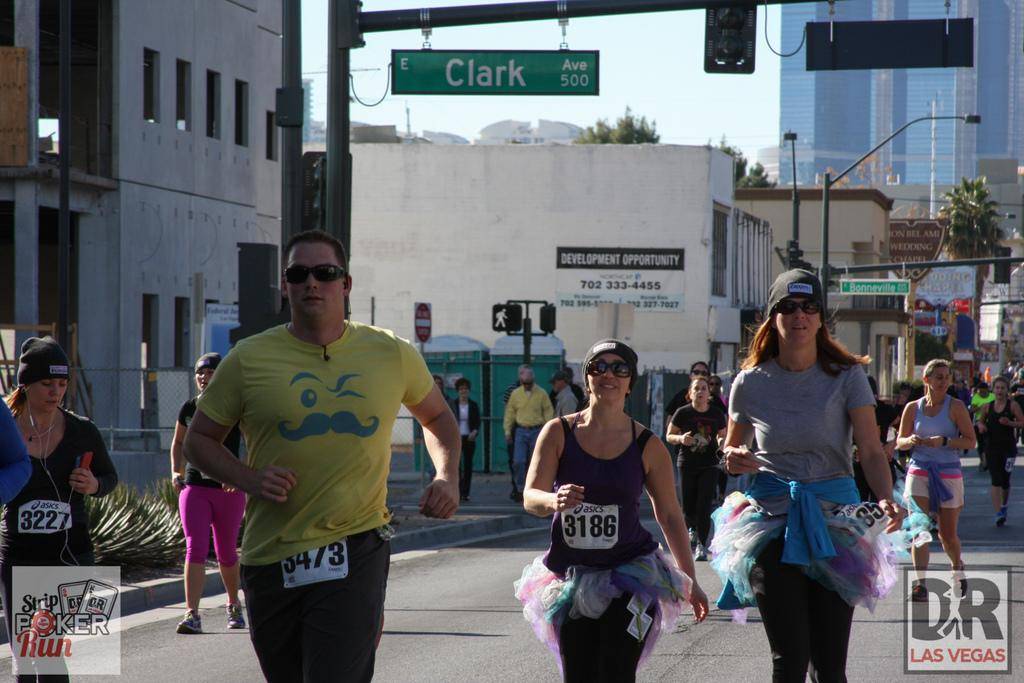What are the people in the image doing? The people in the center of the image are walking and running. What can be seen in the background of the image? There are buildings, poles, trees, and boards with text written on them in the background of the image. What type of destruction can be seen in the image? There is no destruction present in the image; it features people walking and running, as well as various background elements. What type of eggnog is being served in the image? There is no eggnog present in the image; it does not show any food or beverages. 